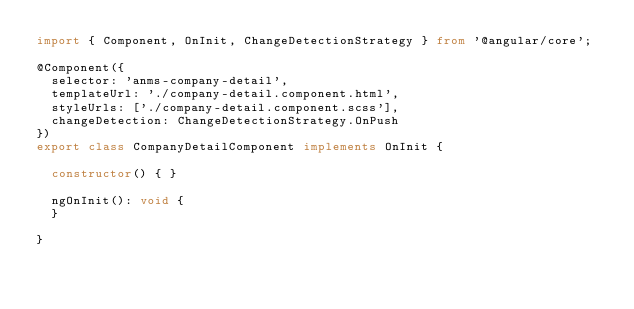<code> <loc_0><loc_0><loc_500><loc_500><_TypeScript_>import { Component, OnInit, ChangeDetectionStrategy } from '@angular/core';

@Component({
  selector: 'anms-company-detail',
  templateUrl: './company-detail.component.html',
  styleUrls: ['./company-detail.component.scss'],
  changeDetection: ChangeDetectionStrategy.OnPush
})
export class CompanyDetailComponent implements OnInit {

  constructor() { }

  ngOnInit(): void {
  }

}
</code> 